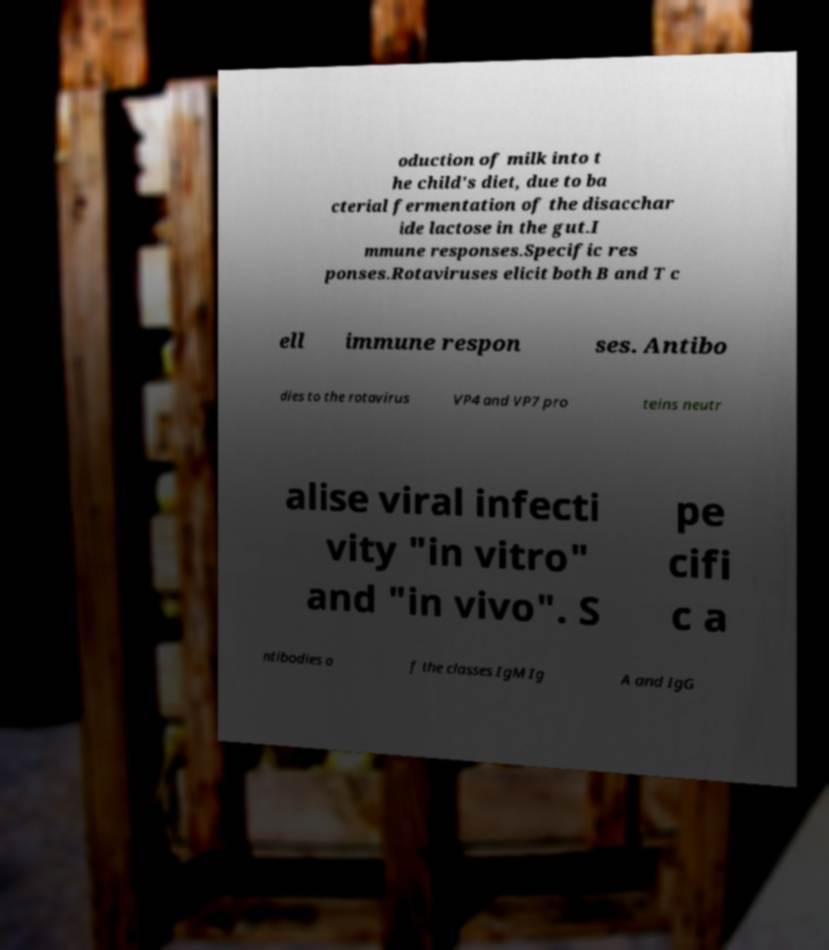Please identify and transcribe the text found in this image. oduction of milk into t he child's diet, due to ba cterial fermentation of the disacchar ide lactose in the gut.I mmune responses.Specific res ponses.Rotaviruses elicit both B and T c ell immune respon ses. Antibo dies to the rotavirus VP4 and VP7 pro teins neutr alise viral infecti vity "in vitro" and "in vivo". S pe cifi c a ntibodies o f the classes IgM Ig A and IgG 